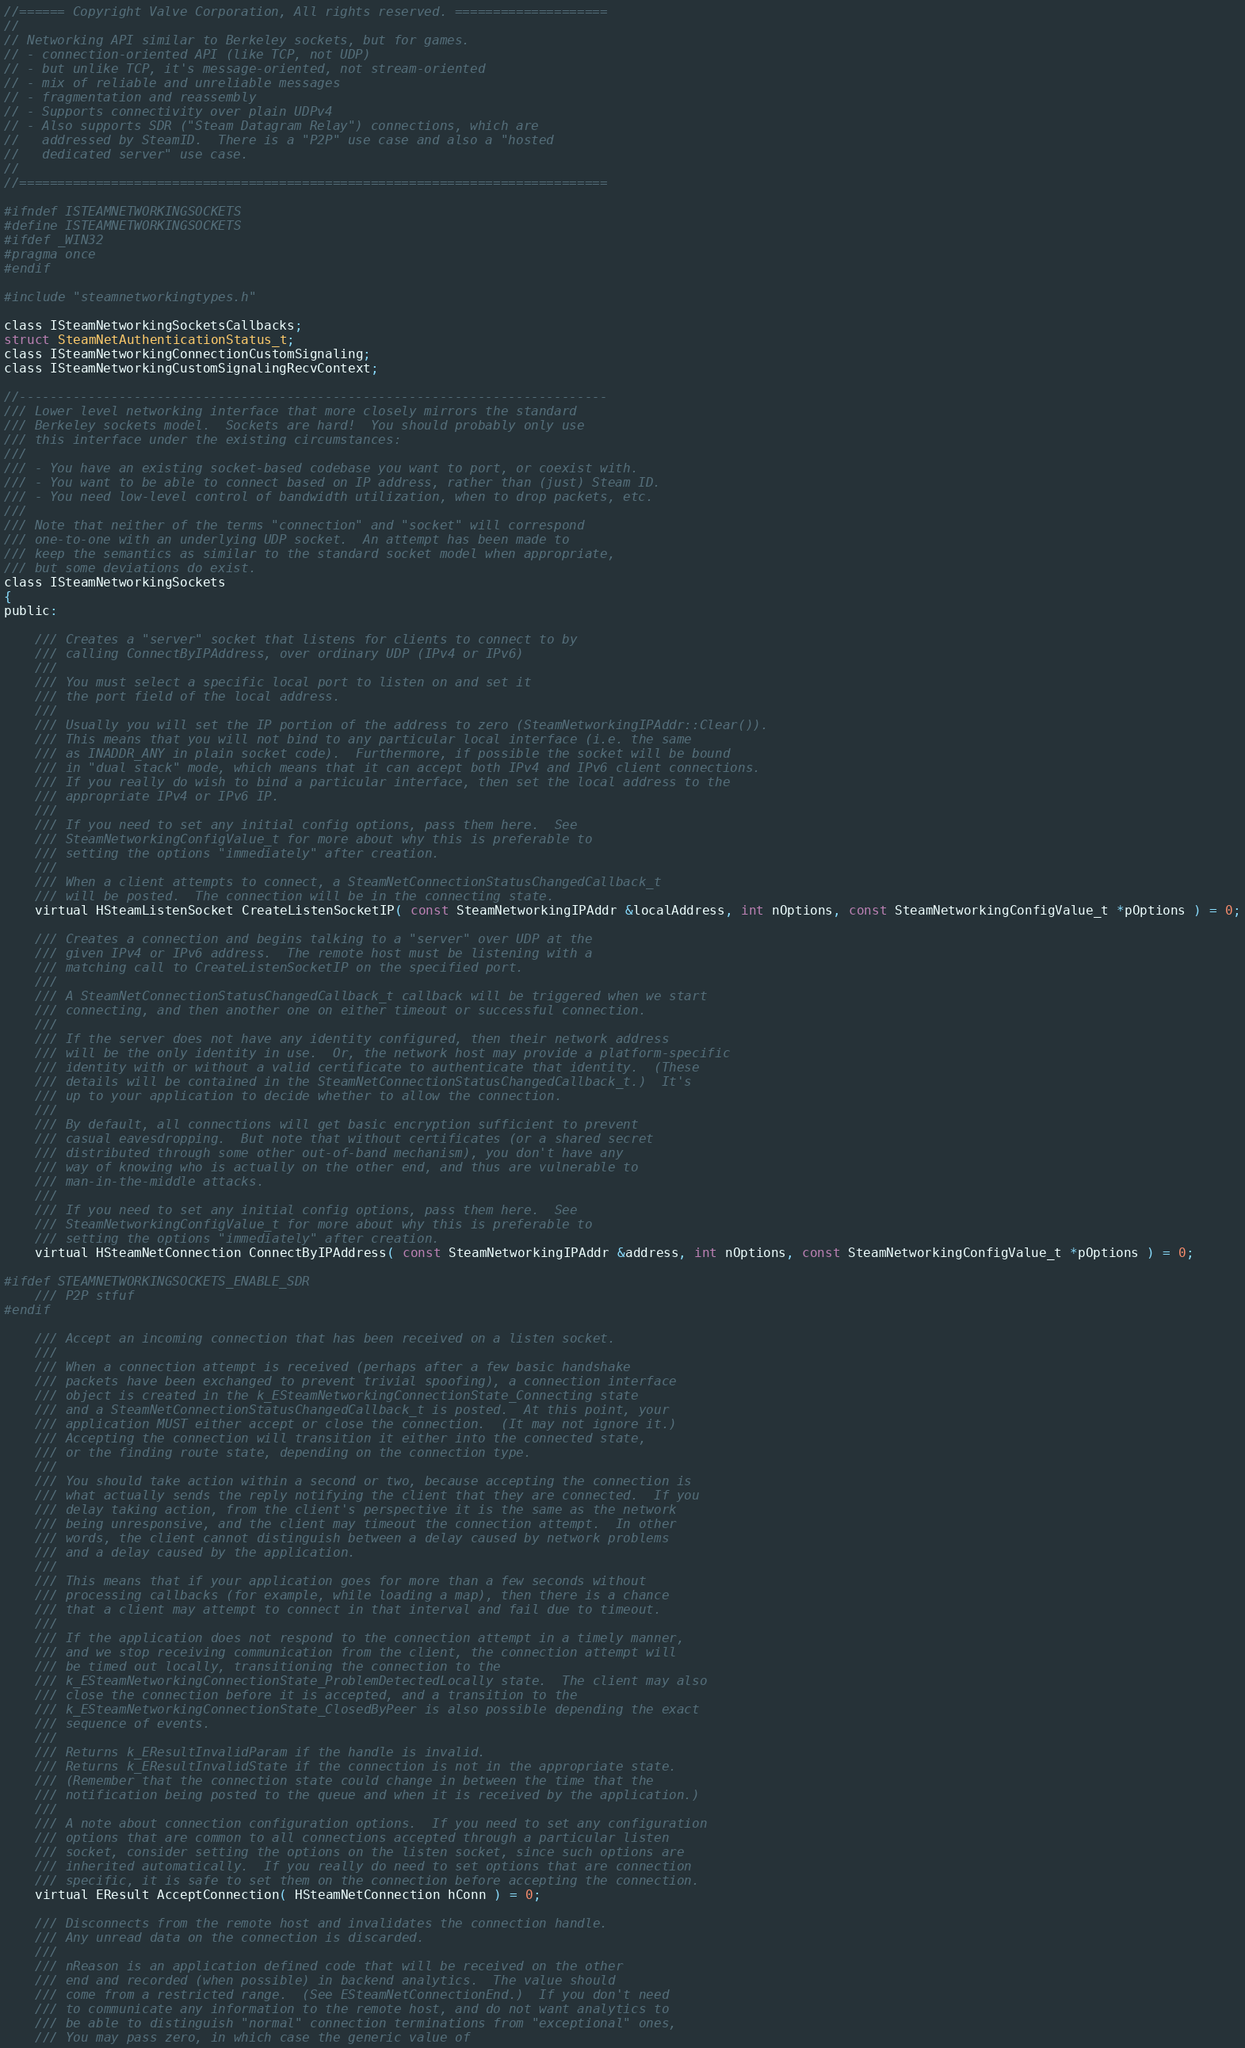<code> <loc_0><loc_0><loc_500><loc_500><_C_>//====== Copyright Valve Corporation, All rights reserved. ====================
//
// Networking API similar to Berkeley sockets, but for games.
// - connection-oriented API (like TCP, not UDP)
// - but unlike TCP, it's message-oriented, not stream-oriented
// - mix of reliable and unreliable messages
// - fragmentation and reassembly
// - Supports connectivity over plain UDPv4
// - Also supports SDR ("Steam Datagram Relay") connections, which are
//   addressed by SteamID.  There is a "P2P" use case and also a "hosted
//   dedicated server" use case.
//
//=============================================================================

#ifndef ISTEAMNETWORKINGSOCKETS
#define ISTEAMNETWORKINGSOCKETS
#ifdef _WIN32
#pragma once
#endif

#include "steamnetworkingtypes.h"

class ISteamNetworkingSocketsCallbacks;
struct SteamNetAuthenticationStatus_t;
class ISteamNetworkingConnectionCustomSignaling;
class ISteamNetworkingCustomSignalingRecvContext;

//-----------------------------------------------------------------------------
/// Lower level networking interface that more closely mirrors the standard
/// Berkeley sockets model.  Sockets are hard!  You should probably only use
/// this interface under the existing circumstances:
///
/// - You have an existing socket-based codebase you want to port, or coexist with.
/// - You want to be able to connect based on IP address, rather than (just) Steam ID.
/// - You need low-level control of bandwidth utilization, when to drop packets, etc.
///
/// Note that neither of the terms "connection" and "socket" will correspond
/// one-to-one with an underlying UDP socket.  An attempt has been made to
/// keep the semantics as similar to the standard socket model when appropriate,
/// but some deviations do exist.
class ISteamNetworkingSockets
{
public:

	/// Creates a "server" socket that listens for clients to connect to by 
	/// calling ConnectByIPAddress, over ordinary UDP (IPv4 or IPv6)
	///
	/// You must select a specific local port to listen on and set it
	/// the port field of the local address.
	///
	/// Usually you will set the IP portion of the address to zero (SteamNetworkingIPAddr::Clear()).
	/// This means that you will not bind to any particular local interface (i.e. the same
	/// as INADDR_ANY in plain socket code).  Furthermore, if possible the socket will be bound
	/// in "dual stack" mode, which means that it can accept both IPv4 and IPv6 client connections.
	/// If you really do wish to bind a particular interface, then set the local address to the
	/// appropriate IPv4 or IPv6 IP.
	///
	/// If you need to set any initial config options, pass them here.  See
	/// SteamNetworkingConfigValue_t for more about why this is preferable to
	/// setting the options "immediately" after creation.
	///
	/// When a client attempts to connect, a SteamNetConnectionStatusChangedCallback_t
	/// will be posted.  The connection will be in the connecting state.
	virtual HSteamListenSocket CreateListenSocketIP( const SteamNetworkingIPAddr &localAddress, int nOptions, const SteamNetworkingConfigValue_t *pOptions ) = 0;

	/// Creates a connection and begins talking to a "server" over UDP at the
	/// given IPv4 or IPv6 address.  The remote host must be listening with a
	/// matching call to CreateListenSocketIP on the specified port.
	///
	/// A SteamNetConnectionStatusChangedCallback_t callback will be triggered when we start
	/// connecting, and then another one on either timeout or successful connection.
	///
	/// If the server does not have any identity configured, then their network address
	/// will be the only identity in use.  Or, the network host may provide a platform-specific
	/// identity with or without a valid certificate to authenticate that identity.  (These
	/// details will be contained in the SteamNetConnectionStatusChangedCallback_t.)  It's
	/// up to your application to decide whether to allow the connection.
	///
	/// By default, all connections will get basic encryption sufficient to prevent
	/// casual eavesdropping.  But note that without certificates (or a shared secret
	/// distributed through some other out-of-band mechanism), you don't have any
	/// way of knowing who is actually on the other end, and thus are vulnerable to
	/// man-in-the-middle attacks.
	///
	/// If you need to set any initial config options, pass them here.  See
	/// SteamNetworkingConfigValue_t for more about why this is preferable to
	/// setting the options "immediately" after creation.
	virtual HSteamNetConnection ConnectByIPAddress( const SteamNetworkingIPAddr &address, int nOptions, const SteamNetworkingConfigValue_t *pOptions ) = 0;

#ifdef STEAMNETWORKINGSOCKETS_ENABLE_SDR
	/// P2P stfuf
#endif

	/// Accept an incoming connection that has been received on a listen socket.
	///
	/// When a connection attempt is received (perhaps after a few basic handshake
	/// packets have been exchanged to prevent trivial spoofing), a connection interface
	/// object is created in the k_ESteamNetworkingConnectionState_Connecting state
	/// and a SteamNetConnectionStatusChangedCallback_t is posted.  At this point, your
	/// application MUST either accept or close the connection.  (It may not ignore it.)
	/// Accepting the connection will transition it either into the connected state,
	/// or the finding route state, depending on the connection type.
	///
	/// You should take action within a second or two, because accepting the connection is
	/// what actually sends the reply notifying the client that they are connected.  If you
	/// delay taking action, from the client's perspective it is the same as the network
	/// being unresponsive, and the client may timeout the connection attempt.  In other
	/// words, the client cannot distinguish between a delay caused by network problems
	/// and a delay caused by the application.
	///
	/// This means that if your application goes for more than a few seconds without
	/// processing callbacks (for example, while loading a map), then there is a chance
	/// that a client may attempt to connect in that interval and fail due to timeout.
	///
	/// If the application does not respond to the connection attempt in a timely manner,
	/// and we stop receiving communication from the client, the connection attempt will
	/// be timed out locally, transitioning the connection to the
	/// k_ESteamNetworkingConnectionState_ProblemDetectedLocally state.  The client may also
	/// close the connection before it is accepted, and a transition to the
	/// k_ESteamNetworkingConnectionState_ClosedByPeer is also possible depending the exact
	/// sequence of events.
	///
	/// Returns k_EResultInvalidParam if the handle is invalid.
	/// Returns k_EResultInvalidState if the connection is not in the appropriate state.
	/// (Remember that the connection state could change in between the time that the
	/// notification being posted to the queue and when it is received by the application.)
	///
	/// A note about connection configuration options.  If you need to set any configuration
	/// options that are common to all connections accepted through a particular listen
	/// socket, consider setting the options on the listen socket, since such options are
	/// inherited automatically.  If you really do need to set options that are connection
	/// specific, it is safe to set them on the connection before accepting the connection.
	virtual EResult AcceptConnection( HSteamNetConnection hConn ) = 0;

	/// Disconnects from the remote host and invalidates the connection handle.
	/// Any unread data on the connection is discarded.
	///
	/// nReason is an application defined code that will be received on the other
	/// end and recorded (when possible) in backend analytics.  The value should
	/// come from a restricted range.  (See ESteamNetConnectionEnd.)  If you don't need
	/// to communicate any information to the remote host, and do not want analytics to
	/// be able to distinguish "normal" connection terminations from "exceptional" ones,
	/// You may pass zero, in which case the generic value of</code> 